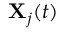<formula> <loc_0><loc_0><loc_500><loc_500>X _ { j } ( t )</formula> 